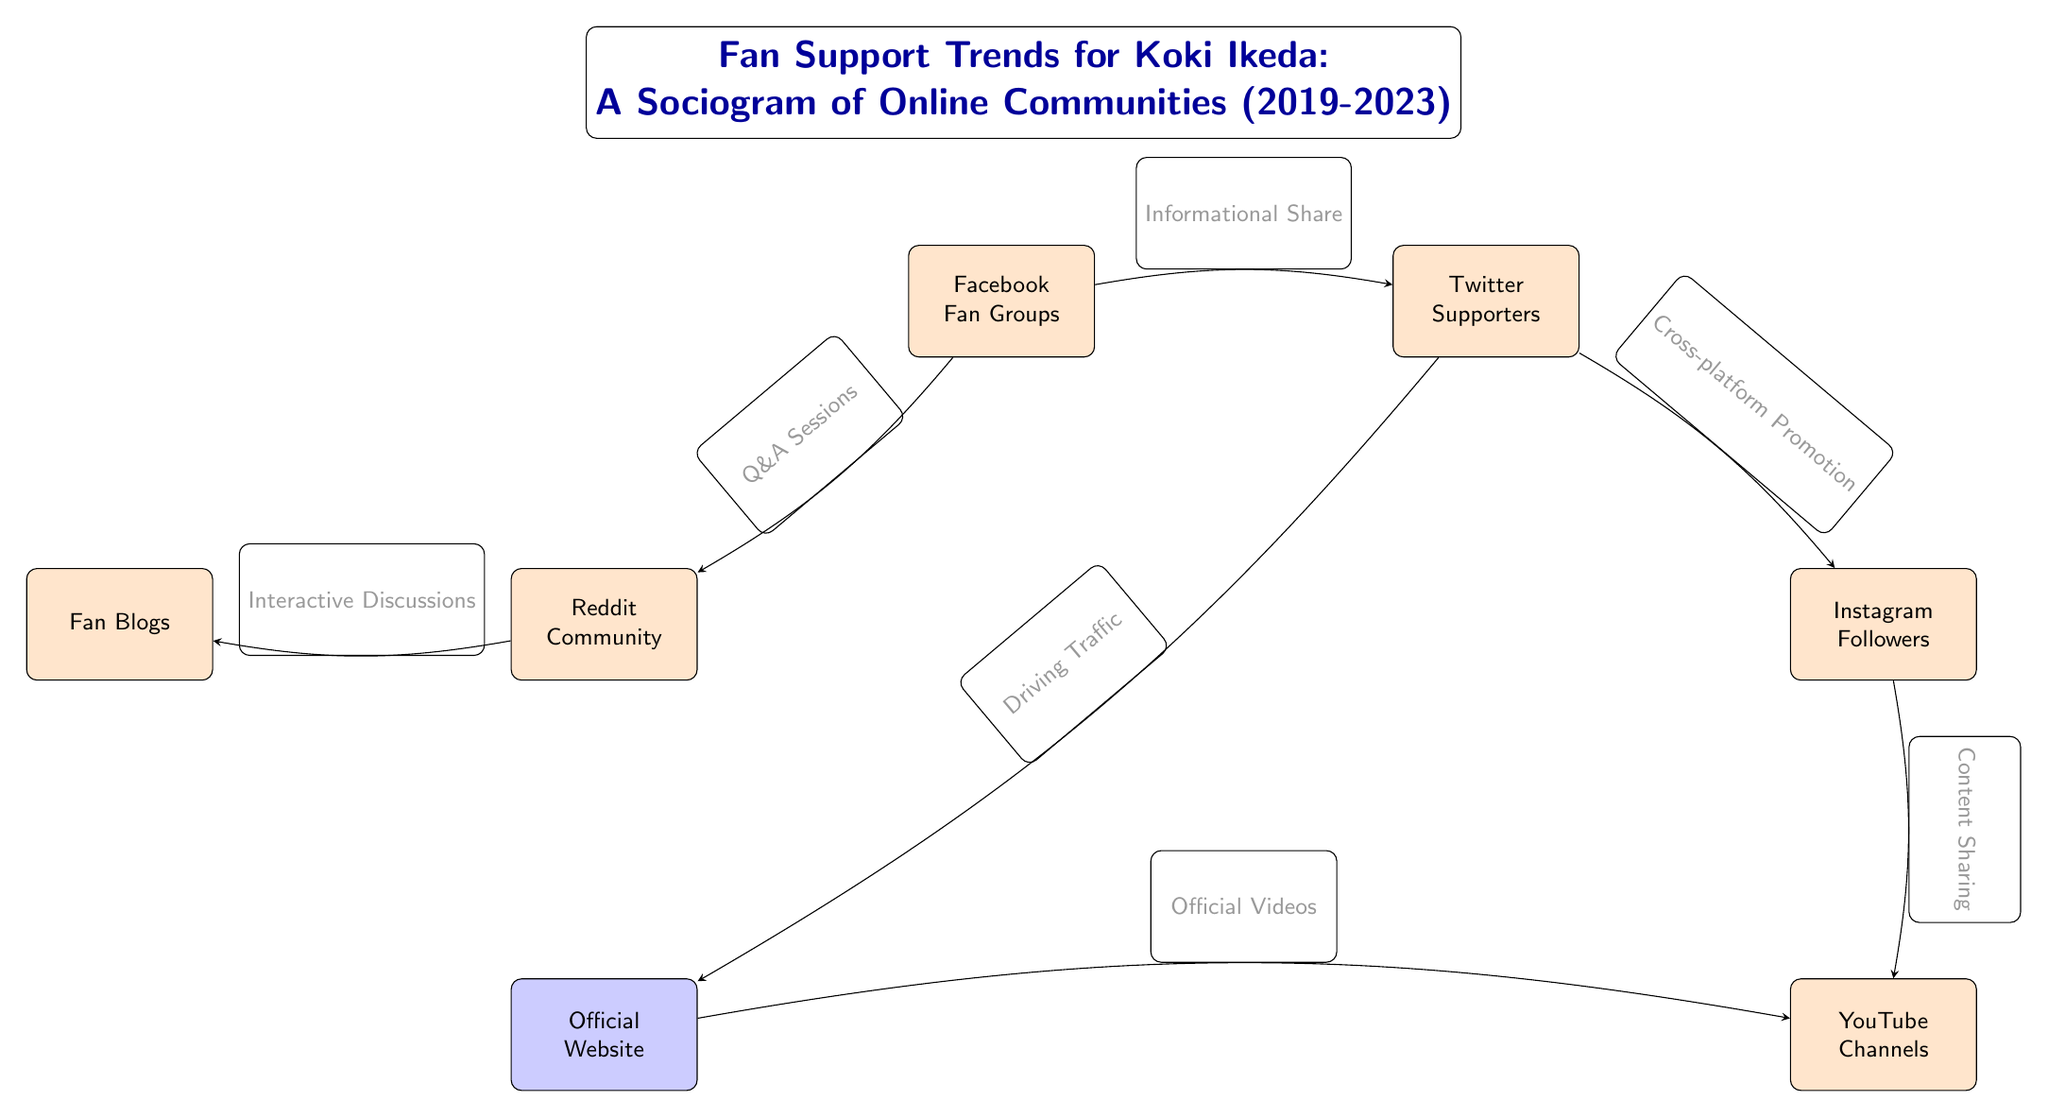What are the main online communities represented in the sociogram? The sociogram contains six main nodes representing different online communities: Facebook Fan Groups, Twitter Supporters, Instagram Followers, Reddit Community, Fan Blogs, and YouTube Channels.
Answer: Facebook Fan Groups, Twitter Supporters, Instagram Followers, Reddit Community, Fan Blogs, YouTube Channels How many edges are present in the diagram? The diagram features a total of seven edges connecting the various online communities, showing the relationships between them.
Answer: 7 Which two nodes have the relationship labeled as "Informational Share"? The nodes with the relationship labeled "Informational Share" are Facebook Fan Groups and Twitter Supporters, indicating that information is shared between these two communities.
Answer: Facebook Fan Groups, Twitter Supporters What type of relationship exists between Twitter Supporters and the Official Website? The relationship between Twitter Supporters and the Official Website is labeled as "Driving Traffic," meaning that Twitter is used to direct users to the official website for Koki Ikeda.
Answer: Driving Traffic Which community is linked to YouTube Channels through "Content Sharing"? Instagram Followers is linked to YouTube Channels through the relationship labeled "Content Sharing," meaning that content created on Instagram is shared on YouTube.
Answer: Instagram Followers What is the function of the Reddit Community in the sociogram? The Reddit Community primarily engages in "Interactive Discussions," showcasing its role as a platform for discussion among fans regarding Koki Ikeda.
Answer: Interactive Discussions How is the connection between the Official Website and YouTube Channels described? The connection is described as "Official Videos," indicating that the Official Website directs users to official videos on the YouTube Channels associated with Koki Ikeda.
Answer: Official Videos 